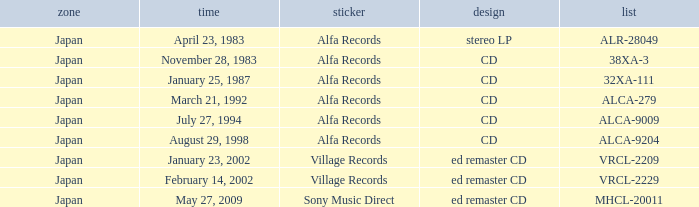What is the format of the date February 14, 2002? Ed remaster cd. 